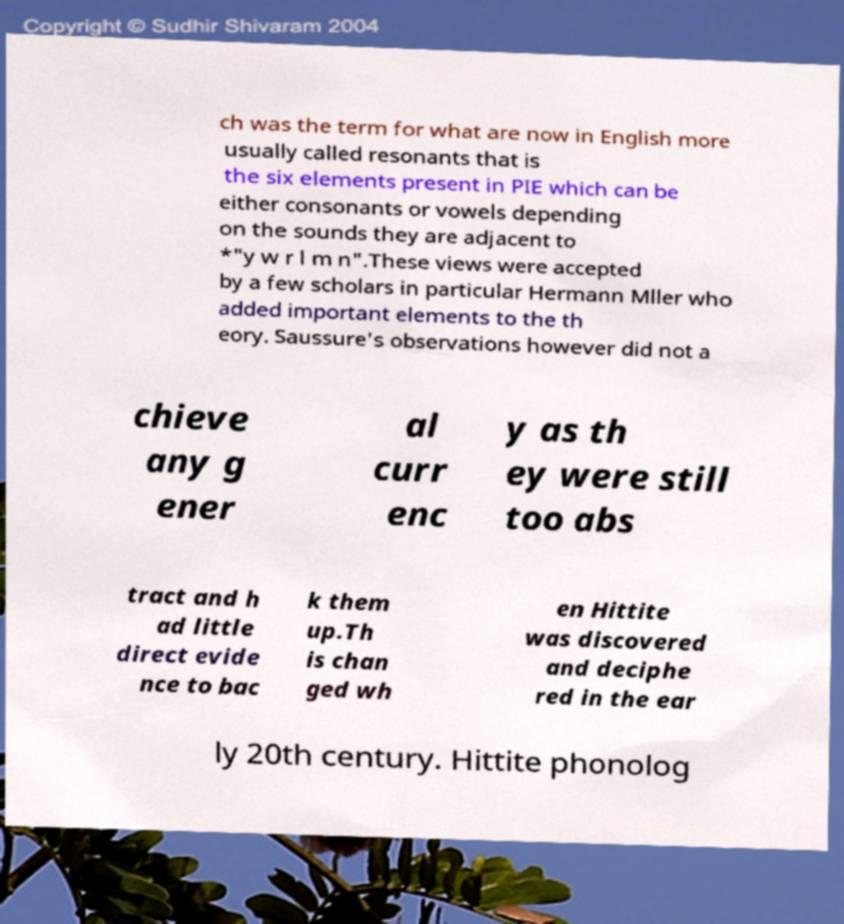Please identify and transcribe the text found in this image. ch was the term for what are now in English more usually called resonants that is the six elements present in PIE which can be either consonants or vowels depending on the sounds they are adjacent to *"y w r l m n".These views were accepted by a few scholars in particular Hermann Mller who added important elements to the th eory. Saussure's observations however did not a chieve any g ener al curr enc y as th ey were still too abs tract and h ad little direct evide nce to bac k them up.Th is chan ged wh en Hittite was discovered and deciphe red in the ear ly 20th century. Hittite phonolog 